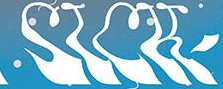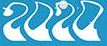Transcribe the words shown in these images in order, separated by a semicolon. SICK; 2020 